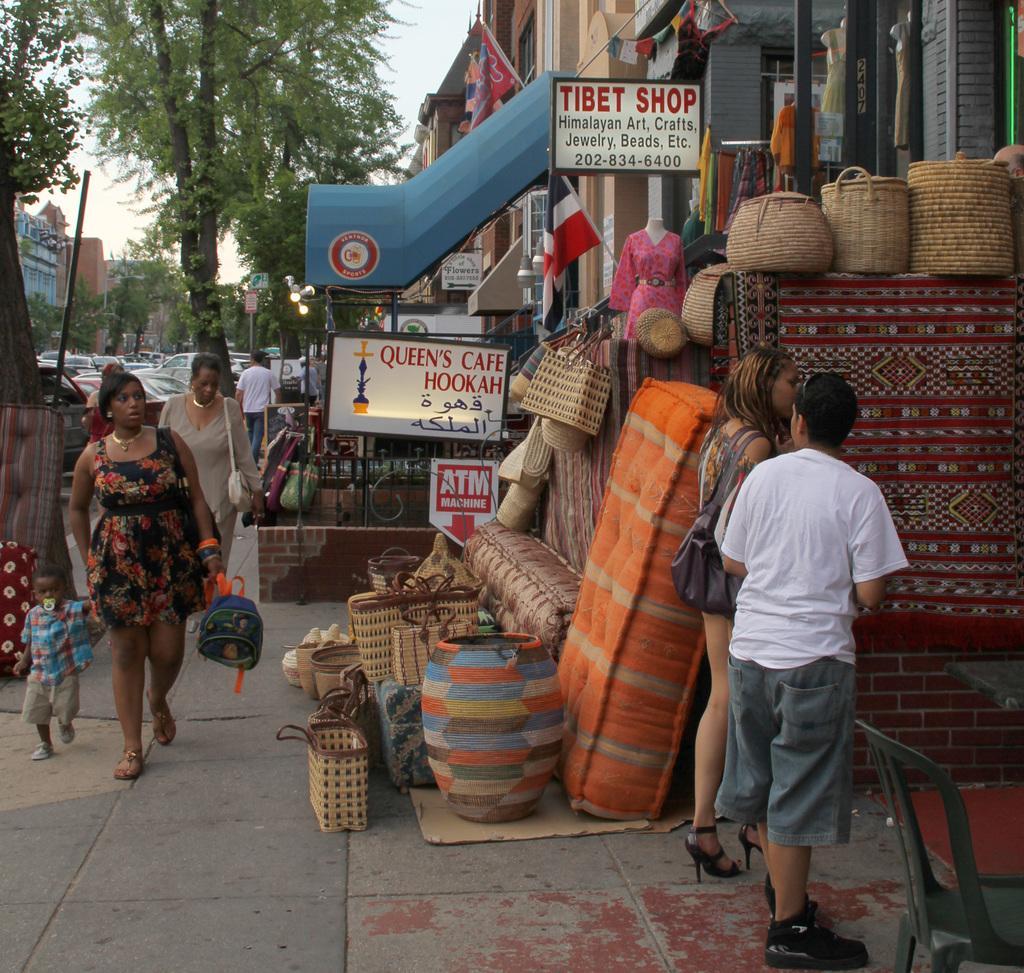Describe this image in one or two sentences. In this picture I can see group of people standing, there is a table, chair, boards, flags, there are mattresses, pot, leaf baskets, buildings, lights, poles, vehicles, trees, mannequins, and in the background there is sky. 